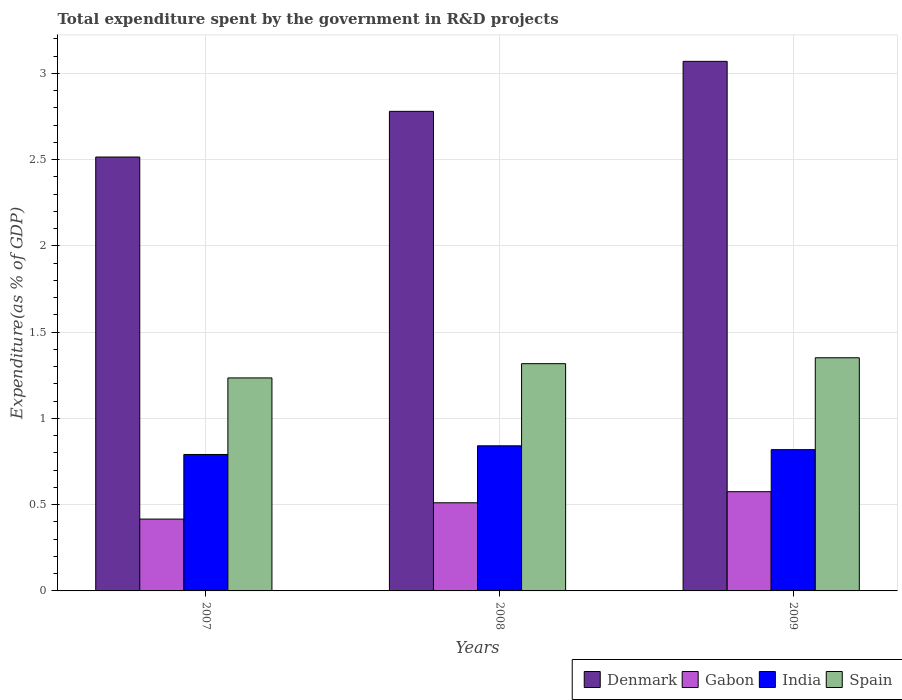How many groups of bars are there?
Keep it short and to the point. 3. Are the number of bars per tick equal to the number of legend labels?
Your answer should be very brief. Yes. How many bars are there on the 1st tick from the left?
Your answer should be compact. 4. How many bars are there on the 2nd tick from the right?
Keep it short and to the point. 4. In how many cases, is the number of bars for a given year not equal to the number of legend labels?
Offer a terse response. 0. What is the total expenditure spent by the government in R&D projects in India in 2007?
Offer a very short reply. 0.79. Across all years, what is the maximum total expenditure spent by the government in R&D projects in India?
Offer a terse response. 0.84. Across all years, what is the minimum total expenditure spent by the government in R&D projects in Denmark?
Offer a very short reply. 2.51. In which year was the total expenditure spent by the government in R&D projects in Denmark maximum?
Your response must be concise. 2009. What is the total total expenditure spent by the government in R&D projects in Gabon in the graph?
Provide a succinct answer. 1.5. What is the difference between the total expenditure spent by the government in R&D projects in Spain in 2008 and that in 2009?
Offer a terse response. -0.03. What is the difference between the total expenditure spent by the government in R&D projects in India in 2008 and the total expenditure spent by the government in R&D projects in Denmark in 2009?
Your answer should be very brief. -2.23. What is the average total expenditure spent by the government in R&D projects in India per year?
Provide a succinct answer. 0.82. In the year 2008, what is the difference between the total expenditure spent by the government in R&D projects in India and total expenditure spent by the government in R&D projects in Denmark?
Give a very brief answer. -1.94. What is the ratio of the total expenditure spent by the government in R&D projects in Gabon in 2007 to that in 2009?
Keep it short and to the point. 0.72. What is the difference between the highest and the second highest total expenditure spent by the government in R&D projects in India?
Offer a very short reply. 0.02. What is the difference between the highest and the lowest total expenditure spent by the government in R&D projects in Gabon?
Your answer should be compact. 0.16. In how many years, is the total expenditure spent by the government in R&D projects in Spain greater than the average total expenditure spent by the government in R&D projects in Spain taken over all years?
Your answer should be very brief. 2. What does the 1st bar from the left in 2009 represents?
Provide a succinct answer. Denmark. Are all the bars in the graph horizontal?
Offer a terse response. No. How many years are there in the graph?
Your response must be concise. 3. What is the difference between two consecutive major ticks on the Y-axis?
Provide a succinct answer. 0.5. Does the graph contain any zero values?
Your answer should be very brief. No. Does the graph contain grids?
Keep it short and to the point. Yes. Where does the legend appear in the graph?
Provide a short and direct response. Bottom right. How are the legend labels stacked?
Give a very brief answer. Horizontal. What is the title of the graph?
Provide a succinct answer. Total expenditure spent by the government in R&D projects. What is the label or title of the Y-axis?
Provide a short and direct response. Expenditure(as % of GDP). What is the Expenditure(as % of GDP) of Denmark in 2007?
Offer a terse response. 2.51. What is the Expenditure(as % of GDP) of Gabon in 2007?
Provide a short and direct response. 0.42. What is the Expenditure(as % of GDP) of India in 2007?
Your answer should be very brief. 0.79. What is the Expenditure(as % of GDP) of Spain in 2007?
Offer a very short reply. 1.23. What is the Expenditure(as % of GDP) of Denmark in 2008?
Ensure brevity in your answer.  2.78. What is the Expenditure(as % of GDP) of Gabon in 2008?
Your response must be concise. 0.51. What is the Expenditure(as % of GDP) in India in 2008?
Provide a succinct answer. 0.84. What is the Expenditure(as % of GDP) in Spain in 2008?
Ensure brevity in your answer.  1.32. What is the Expenditure(as % of GDP) in Denmark in 2009?
Offer a very short reply. 3.07. What is the Expenditure(as % of GDP) of Gabon in 2009?
Provide a succinct answer. 0.58. What is the Expenditure(as % of GDP) in India in 2009?
Make the answer very short. 0.82. What is the Expenditure(as % of GDP) in Spain in 2009?
Your answer should be compact. 1.35. Across all years, what is the maximum Expenditure(as % of GDP) in Denmark?
Offer a terse response. 3.07. Across all years, what is the maximum Expenditure(as % of GDP) in Gabon?
Make the answer very short. 0.58. Across all years, what is the maximum Expenditure(as % of GDP) in India?
Your answer should be compact. 0.84. Across all years, what is the maximum Expenditure(as % of GDP) in Spain?
Provide a succinct answer. 1.35. Across all years, what is the minimum Expenditure(as % of GDP) in Denmark?
Offer a very short reply. 2.51. Across all years, what is the minimum Expenditure(as % of GDP) in Gabon?
Your answer should be very brief. 0.42. Across all years, what is the minimum Expenditure(as % of GDP) in India?
Ensure brevity in your answer.  0.79. Across all years, what is the minimum Expenditure(as % of GDP) of Spain?
Make the answer very short. 1.23. What is the total Expenditure(as % of GDP) in Denmark in the graph?
Provide a succinct answer. 8.36. What is the total Expenditure(as % of GDP) of Gabon in the graph?
Your answer should be very brief. 1.5. What is the total Expenditure(as % of GDP) of India in the graph?
Your response must be concise. 2.45. What is the total Expenditure(as % of GDP) in Spain in the graph?
Give a very brief answer. 3.9. What is the difference between the Expenditure(as % of GDP) of Denmark in 2007 and that in 2008?
Ensure brevity in your answer.  -0.26. What is the difference between the Expenditure(as % of GDP) in Gabon in 2007 and that in 2008?
Provide a short and direct response. -0.09. What is the difference between the Expenditure(as % of GDP) of India in 2007 and that in 2008?
Provide a short and direct response. -0.05. What is the difference between the Expenditure(as % of GDP) of Spain in 2007 and that in 2008?
Ensure brevity in your answer.  -0.08. What is the difference between the Expenditure(as % of GDP) in Denmark in 2007 and that in 2009?
Give a very brief answer. -0.55. What is the difference between the Expenditure(as % of GDP) of Gabon in 2007 and that in 2009?
Your answer should be compact. -0.16. What is the difference between the Expenditure(as % of GDP) of India in 2007 and that in 2009?
Offer a very short reply. -0.03. What is the difference between the Expenditure(as % of GDP) of Spain in 2007 and that in 2009?
Your answer should be compact. -0.12. What is the difference between the Expenditure(as % of GDP) in Denmark in 2008 and that in 2009?
Provide a short and direct response. -0.29. What is the difference between the Expenditure(as % of GDP) in Gabon in 2008 and that in 2009?
Ensure brevity in your answer.  -0.06. What is the difference between the Expenditure(as % of GDP) of India in 2008 and that in 2009?
Make the answer very short. 0.02. What is the difference between the Expenditure(as % of GDP) of Spain in 2008 and that in 2009?
Keep it short and to the point. -0.03. What is the difference between the Expenditure(as % of GDP) in Denmark in 2007 and the Expenditure(as % of GDP) in Gabon in 2008?
Ensure brevity in your answer.  2. What is the difference between the Expenditure(as % of GDP) of Denmark in 2007 and the Expenditure(as % of GDP) of India in 2008?
Provide a short and direct response. 1.67. What is the difference between the Expenditure(as % of GDP) in Denmark in 2007 and the Expenditure(as % of GDP) in Spain in 2008?
Give a very brief answer. 1.2. What is the difference between the Expenditure(as % of GDP) in Gabon in 2007 and the Expenditure(as % of GDP) in India in 2008?
Give a very brief answer. -0.42. What is the difference between the Expenditure(as % of GDP) of Gabon in 2007 and the Expenditure(as % of GDP) of Spain in 2008?
Your answer should be compact. -0.9. What is the difference between the Expenditure(as % of GDP) of India in 2007 and the Expenditure(as % of GDP) of Spain in 2008?
Make the answer very short. -0.53. What is the difference between the Expenditure(as % of GDP) of Denmark in 2007 and the Expenditure(as % of GDP) of Gabon in 2009?
Provide a succinct answer. 1.94. What is the difference between the Expenditure(as % of GDP) of Denmark in 2007 and the Expenditure(as % of GDP) of India in 2009?
Give a very brief answer. 1.7. What is the difference between the Expenditure(as % of GDP) of Denmark in 2007 and the Expenditure(as % of GDP) of Spain in 2009?
Provide a short and direct response. 1.16. What is the difference between the Expenditure(as % of GDP) of Gabon in 2007 and the Expenditure(as % of GDP) of India in 2009?
Provide a short and direct response. -0.4. What is the difference between the Expenditure(as % of GDP) of Gabon in 2007 and the Expenditure(as % of GDP) of Spain in 2009?
Provide a short and direct response. -0.94. What is the difference between the Expenditure(as % of GDP) in India in 2007 and the Expenditure(as % of GDP) in Spain in 2009?
Your response must be concise. -0.56. What is the difference between the Expenditure(as % of GDP) in Denmark in 2008 and the Expenditure(as % of GDP) in Gabon in 2009?
Ensure brevity in your answer.  2.2. What is the difference between the Expenditure(as % of GDP) of Denmark in 2008 and the Expenditure(as % of GDP) of India in 2009?
Offer a very short reply. 1.96. What is the difference between the Expenditure(as % of GDP) in Denmark in 2008 and the Expenditure(as % of GDP) in Spain in 2009?
Offer a very short reply. 1.43. What is the difference between the Expenditure(as % of GDP) of Gabon in 2008 and the Expenditure(as % of GDP) of India in 2009?
Keep it short and to the point. -0.31. What is the difference between the Expenditure(as % of GDP) in Gabon in 2008 and the Expenditure(as % of GDP) in Spain in 2009?
Give a very brief answer. -0.84. What is the difference between the Expenditure(as % of GDP) in India in 2008 and the Expenditure(as % of GDP) in Spain in 2009?
Give a very brief answer. -0.51. What is the average Expenditure(as % of GDP) in Denmark per year?
Offer a terse response. 2.79. What is the average Expenditure(as % of GDP) in Gabon per year?
Your answer should be compact. 0.5. What is the average Expenditure(as % of GDP) of India per year?
Offer a very short reply. 0.82. What is the average Expenditure(as % of GDP) of Spain per year?
Give a very brief answer. 1.3. In the year 2007, what is the difference between the Expenditure(as % of GDP) in Denmark and Expenditure(as % of GDP) in Gabon?
Provide a succinct answer. 2.1. In the year 2007, what is the difference between the Expenditure(as % of GDP) in Denmark and Expenditure(as % of GDP) in India?
Give a very brief answer. 1.72. In the year 2007, what is the difference between the Expenditure(as % of GDP) in Denmark and Expenditure(as % of GDP) in Spain?
Make the answer very short. 1.28. In the year 2007, what is the difference between the Expenditure(as % of GDP) of Gabon and Expenditure(as % of GDP) of India?
Offer a terse response. -0.37. In the year 2007, what is the difference between the Expenditure(as % of GDP) in Gabon and Expenditure(as % of GDP) in Spain?
Your answer should be very brief. -0.82. In the year 2007, what is the difference between the Expenditure(as % of GDP) of India and Expenditure(as % of GDP) of Spain?
Offer a very short reply. -0.44. In the year 2008, what is the difference between the Expenditure(as % of GDP) in Denmark and Expenditure(as % of GDP) in Gabon?
Your answer should be very brief. 2.27. In the year 2008, what is the difference between the Expenditure(as % of GDP) of Denmark and Expenditure(as % of GDP) of India?
Offer a very short reply. 1.94. In the year 2008, what is the difference between the Expenditure(as % of GDP) in Denmark and Expenditure(as % of GDP) in Spain?
Provide a succinct answer. 1.46. In the year 2008, what is the difference between the Expenditure(as % of GDP) in Gabon and Expenditure(as % of GDP) in India?
Give a very brief answer. -0.33. In the year 2008, what is the difference between the Expenditure(as % of GDP) in Gabon and Expenditure(as % of GDP) in Spain?
Provide a succinct answer. -0.81. In the year 2008, what is the difference between the Expenditure(as % of GDP) in India and Expenditure(as % of GDP) in Spain?
Provide a short and direct response. -0.48. In the year 2009, what is the difference between the Expenditure(as % of GDP) in Denmark and Expenditure(as % of GDP) in Gabon?
Ensure brevity in your answer.  2.49. In the year 2009, what is the difference between the Expenditure(as % of GDP) in Denmark and Expenditure(as % of GDP) in India?
Give a very brief answer. 2.25. In the year 2009, what is the difference between the Expenditure(as % of GDP) of Denmark and Expenditure(as % of GDP) of Spain?
Offer a terse response. 1.72. In the year 2009, what is the difference between the Expenditure(as % of GDP) in Gabon and Expenditure(as % of GDP) in India?
Give a very brief answer. -0.24. In the year 2009, what is the difference between the Expenditure(as % of GDP) of Gabon and Expenditure(as % of GDP) of Spain?
Your response must be concise. -0.78. In the year 2009, what is the difference between the Expenditure(as % of GDP) in India and Expenditure(as % of GDP) in Spain?
Keep it short and to the point. -0.53. What is the ratio of the Expenditure(as % of GDP) in Denmark in 2007 to that in 2008?
Your response must be concise. 0.9. What is the ratio of the Expenditure(as % of GDP) of Gabon in 2007 to that in 2008?
Your answer should be compact. 0.81. What is the ratio of the Expenditure(as % of GDP) of India in 2007 to that in 2008?
Provide a short and direct response. 0.94. What is the ratio of the Expenditure(as % of GDP) of Spain in 2007 to that in 2008?
Offer a terse response. 0.94. What is the ratio of the Expenditure(as % of GDP) of Denmark in 2007 to that in 2009?
Provide a short and direct response. 0.82. What is the ratio of the Expenditure(as % of GDP) of Gabon in 2007 to that in 2009?
Your answer should be compact. 0.72. What is the ratio of the Expenditure(as % of GDP) in India in 2007 to that in 2009?
Offer a very short reply. 0.97. What is the ratio of the Expenditure(as % of GDP) in Spain in 2007 to that in 2009?
Your answer should be very brief. 0.91. What is the ratio of the Expenditure(as % of GDP) in Denmark in 2008 to that in 2009?
Provide a short and direct response. 0.91. What is the ratio of the Expenditure(as % of GDP) in Gabon in 2008 to that in 2009?
Offer a very short reply. 0.89. What is the ratio of the Expenditure(as % of GDP) in India in 2008 to that in 2009?
Provide a succinct answer. 1.03. What is the ratio of the Expenditure(as % of GDP) in Spain in 2008 to that in 2009?
Your answer should be very brief. 0.97. What is the difference between the highest and the second highest Expenditure(as % of GDP) of Denmark?
Your answer should be compact. 0.29. What is the difference between the highest and the second highest Expenditure(as % of GDP) in Gabon?
Your response must be concise. 0.06. What is the difference between the highest and the second highest Expenditure(as % of GDP) of India?
Ensure brevity in your answer.  0.02. What is the difference between the highest and the second highest Expenditure(as % of GDP) in Spain?
Provide a succinct answer. 0.03. What is the difference between the highest and the lowest Expenditure(as % of GDP) of Denmark?
Provide a succinct answer. 0.55. What is the difference between the highest and the lowest Expenditure(as % of GDP) in Gabon?
Make the answer very short. 0.16. What is the difference between the highest and the lowest Expenditure(as % of GDP) of India?
Offer a terse response. 0.05. What is the difference between the highest and the lowest Expenditure(as % of GDP) of Spain?
Offer a terse response. 0.12. 